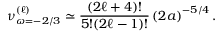<formula> <loc_0><loc_0><loc_500><loc_500>\nu _ { \omega = - 2 / 3 } ^ { ( \ell ) } \simeq \frac { ( 2 \ell + 4 ) ! } { 5 ! ( 2 \ell - 1 ) ! } \left ( 2 a \right ) ^ { - 5 / 4 } .</formula> 